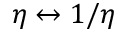Convert formula to latex. <formula><loc_0><loc_0><loc_500><loc_500>\eta \leftrightarrow 1 / \eta</formula> 